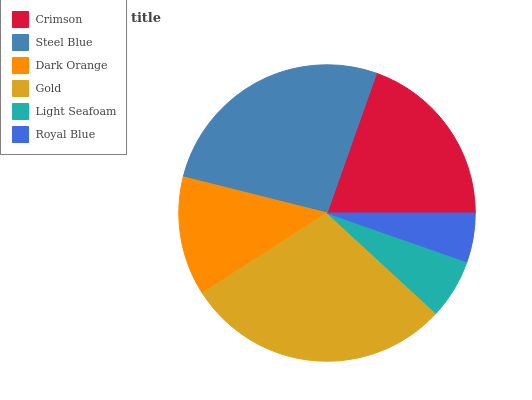Is Royal Blue the minimum?
Answer yes or no. Yes. Is Gold the maximum?
Answer yes or no. Yes. Is Steel Blue the minimum?
Answer yes or no. No. Is Steel Blue the maximum?
Answer yes or no. No. Is Steel Blue greater than Crimson?
Answer yes or no. Yes. Is Crimson less than Steel Blue?
Answer yes or no. Yes. Is Crimson greater than Steel Blue?
Answer yes or no. No. Is Steel Blue less than Crimson?
Answer yes or no. No. Is Crimson the high median?
Answer yes or no. Yes. Is Dark Orange the low median?
Answer yes or no. Yes. Is Light Seafoam the high median?
Answer yes or no. No. Is Crimson the low median?
Answer yes or no. No. 